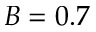Convert formula to latex. <formula><loc_0><loc_0><loc_500><loc_500>B = 0 . 7</formula> 